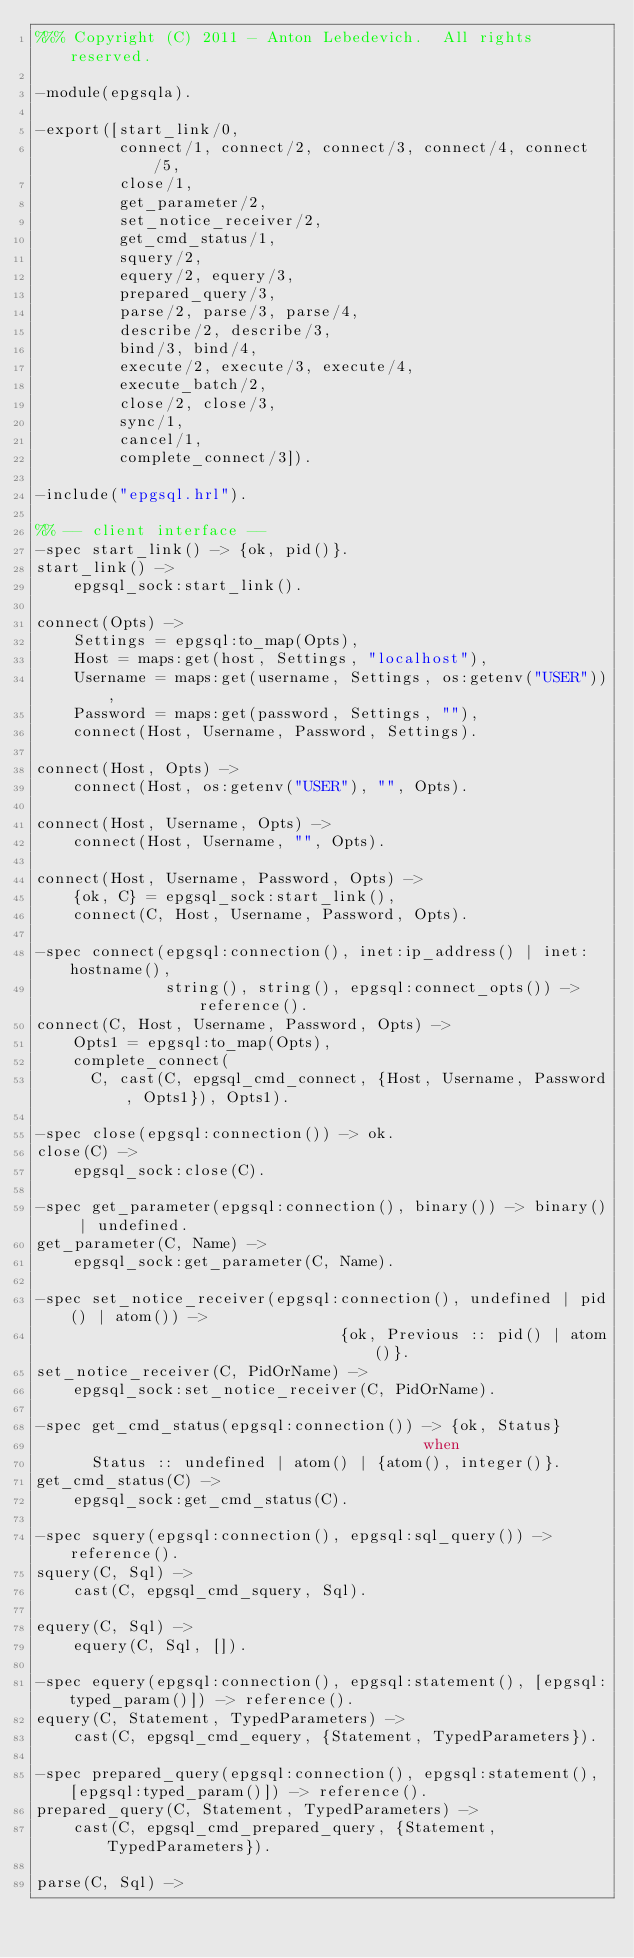Convert code to text. <code><loc_0><loc_0><loc_500><loc_500><_Erlang_>%%% Copyright (C) 2011 - Anton Lebedevich.  All rights reserved.

-module(epgsqla).

-export([start_link/0,
         connect/1, connect/2, connect/3, connect/4, connect/5,
         close/1,
         get_parameter/2,
         set_notice_receiver/2,
         get_cmd_status/1,
         squery/2,
         equery/2, equery/3,
         prepared_query/3,
         parse/2, parse/3, parse/4,
         describe/2, describe/3,
         bind/3, bind/4,
         execute/2, execute/3, execute/4,
         execute_batch/2,
         close/2, close/3,
         sync/1,
         cancel/1,
         complete_connect/3]).

-include("epgsql.hrl").

%% -- client interface --
-spec start_link() -> {ok, pid()}.
start_link() ->
    epgsql_sock:start_link().

connect(Opts) ->
    Settings = epgsql:to_map(Opts),
    Host = maps:get(host, Settings, "localhost"),
    Username = maps:get(username, Settings, os:getenv("USER")),
    Password = maps:get(password, Settings, ""),
    connect(Host, Username, Password, Settings).

connect(Host, Opts) ->
    connect(Host, os:getenv("USER"), "", Opts).

connect(Host, Username, Opts) ->
    connect(Host, Username, "", Opts).

connect(Host, Username, Password, Opts) ->
    {ok, C} = epgsql_sock:start_link(),
    connect(C, Host, Username, Password, Opts).

-spec connect(epgsql:connection(), inet:ip_address() | inet:hostname(),
              string(), string(), epgsql:connect_opts()) -> reference().
connect(C, Host, Username, Password, Opts) ->
    Opts1 = epgsql:to_map(Opts),
    complete_connect(
      C, cast(C, epgsql_cmd_connect, {Host, Username, Password, Opts1}), Opts1).

-spec close(epgsql:connection()) -> ok.
close(C) ->
    epgsql_sock:close(C).

-spec get_parameter(epgsql:connection(), binary()) -> binary() | undefined.
get_parameter(C, Name) ->
    epgsql_sock:get_parameter(C, Name).

-spec set_notice_receiver(epgsql:connection(), undefined | pid() | atom()) ->
                                 {ok, Previous :: pid() | atom()}.
set_notice_receiver(C, PidOrName) ->
    epgsql_sock:set_notice_receiver(C, PidOrName).

-spec get_cmd_status(epgsql:connection()) -> {ok, Status}
                                          when
      Status :: undefined | atom() | {atom(), integer()}.
get_cmd_status(C) ->
    epgsql_sock:get_cmd_status(C).

-spec squery(epgsql:connection(), epgsql:sql_query()) -> reference().
squery(C, Sql) ->
    cast(C, epgsql_cmd_squery, Sql).

equery(C, Sql) ->
    equery(C, Sql, []).

-spec equery(epgsql:connection(), epgsql:statement(), [epgsql:typed_param()]) -> reference().
equery(C, Statement, TypedParameters) ->
    cast(C, epgsql_cmd_equery, {Statement, TypedParameters}).

-spec prepared_query(epgsql:connection(), epgsql:statement(), [epgsql:typed_param()]) -> reference().
prepared_query(C, Statement, TypedParameters) ->
    cast(C, epgsql_cmd_prepared_query, {Statement, TypedParameters}).

parse(C, Sql) -></code> 